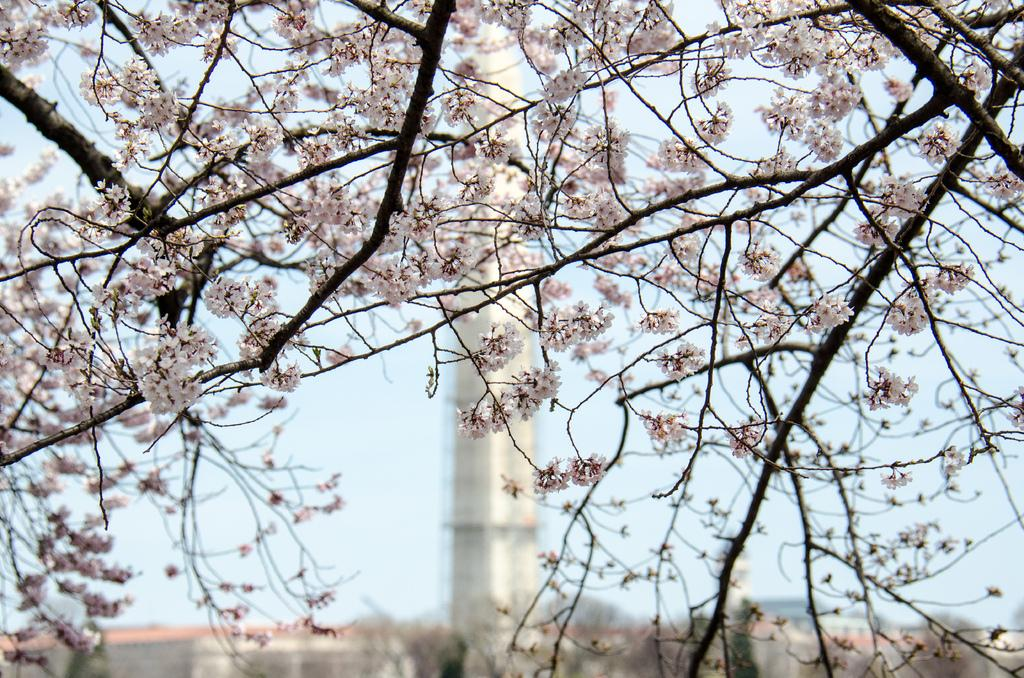What type of vegetation is present in the image? There are branches of a tree with flowers in the image. What structure can be seen in the background of the image? There is a tower in the background of the image. What part of the natural environment is visible in the image? The sky is visible in the background of the image. Where is the giraffe located in the image? There is no giraffe present in the image. What type of writer can be seen working on their manuscript in the image? There is no writer or manuscript present in the image. 